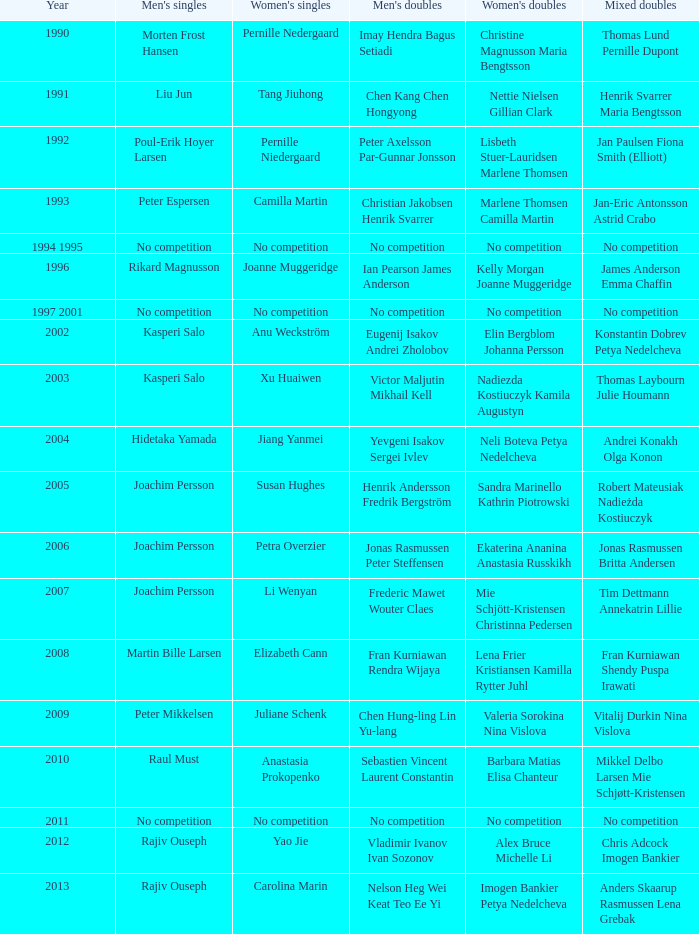Who won the Mixed Doubles in 2007? Tim Dettmann Annekatrin Lillie. 